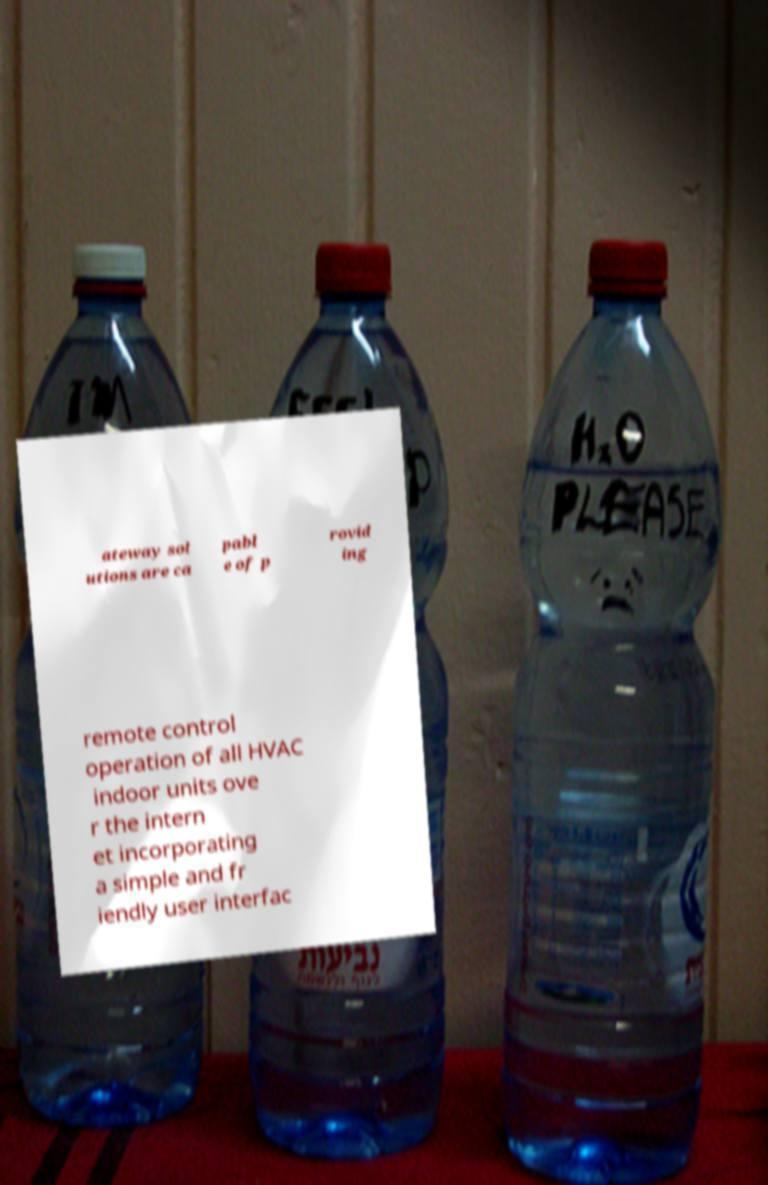I need the written content from this picture converted into text. Can you do that? ateway sol utions are ca pabl e of p rovid ing remote control operation of all HVAC indoor units ove r the intern et incorporating a simple and fr iendly user interfac 